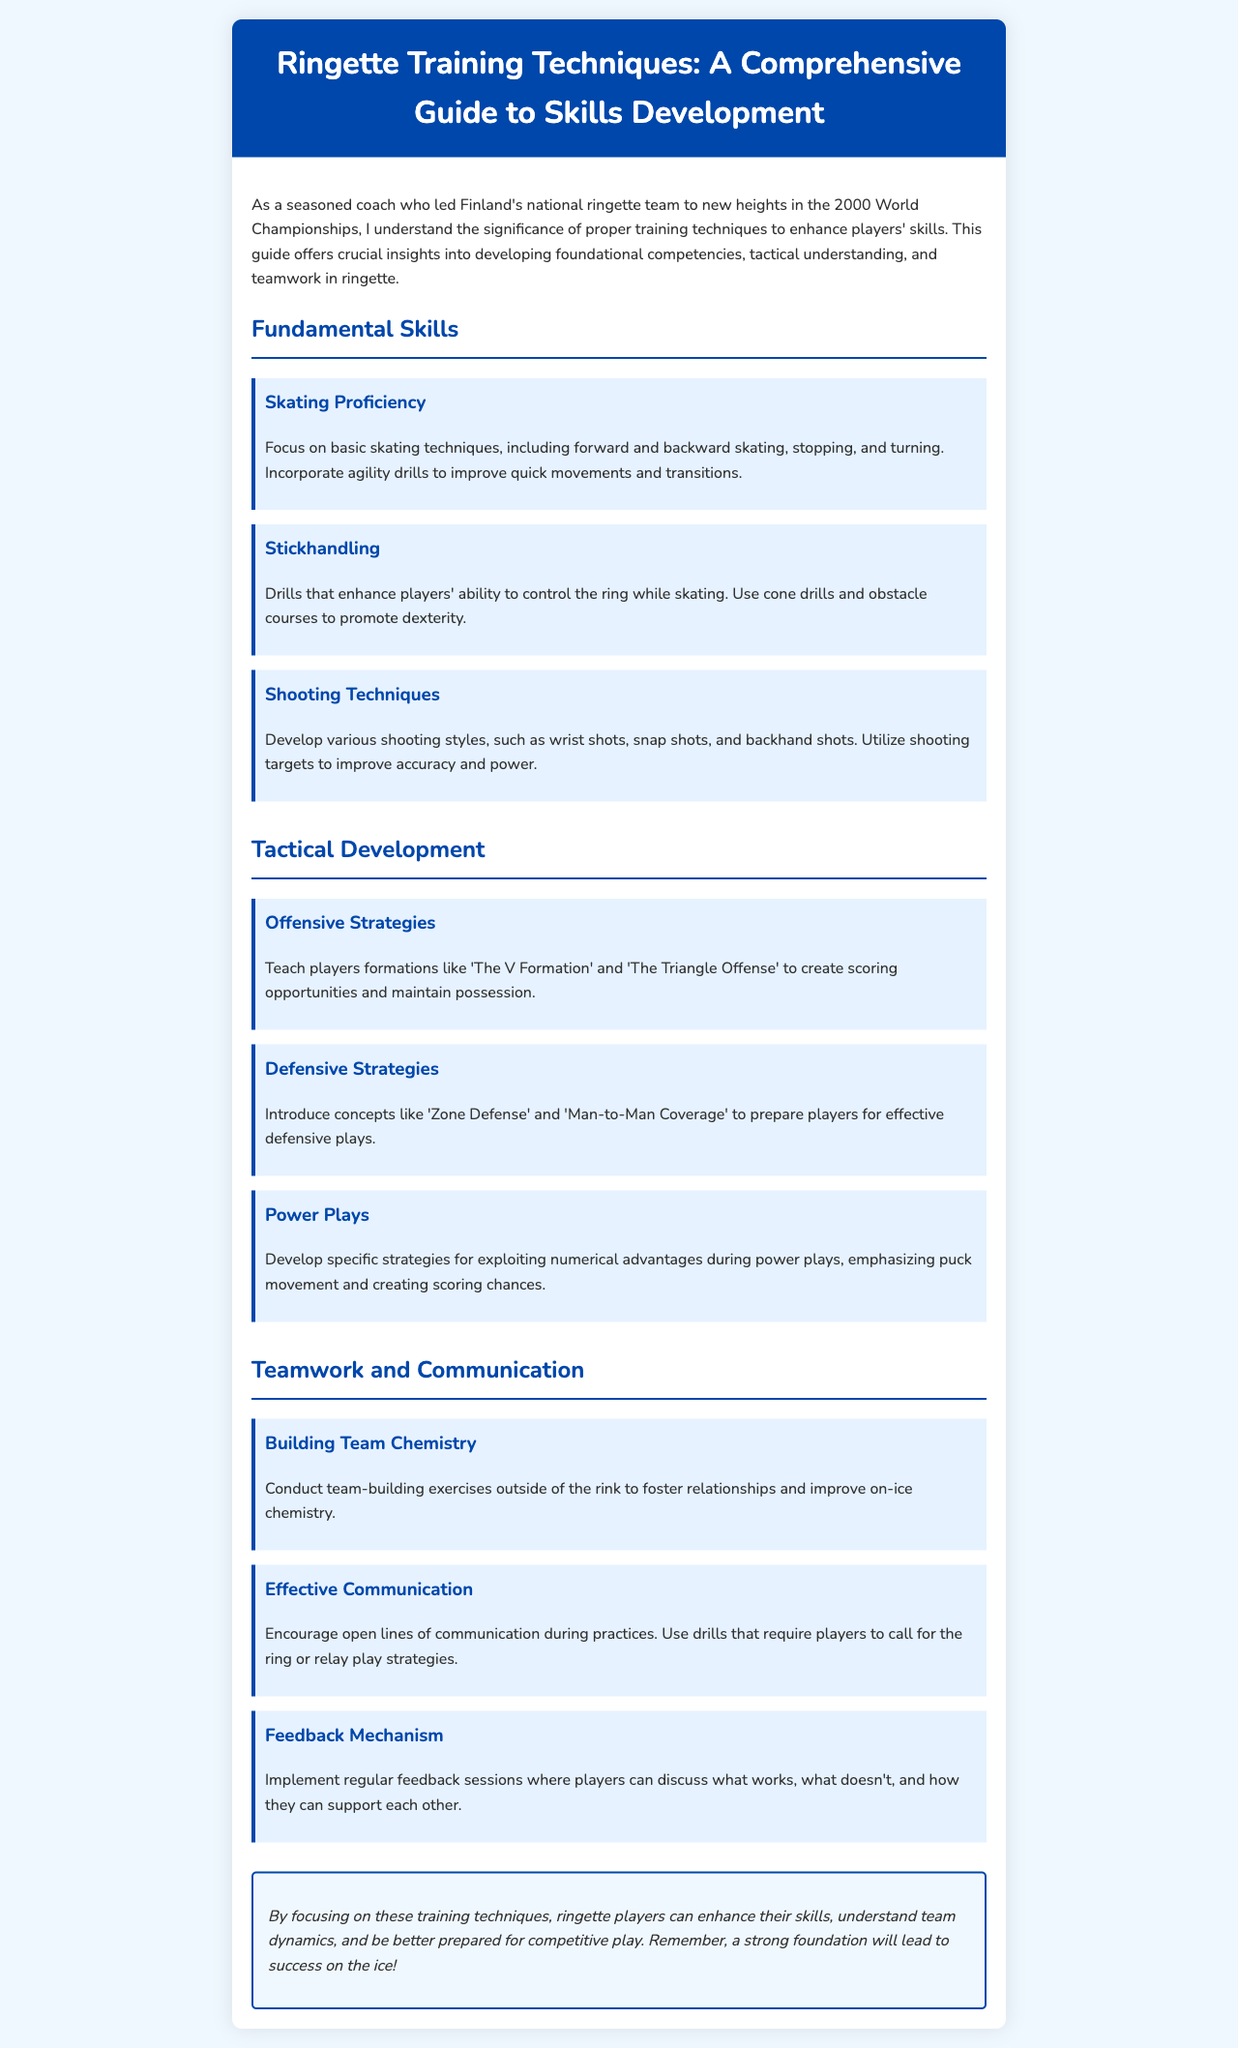What is the title of the brochure? The title of the brochure is presented in the header section, which introduces the main topic of the document.
Answer: Ringette Training Techniques: A Comprehensive Guide to Skills Development Who led Finland's national ringette team in the 2000 World Championships? The document mentions the author as a seasoned coach who guided the team in the 2000 World Championships, indicating their experience.
Answer: The author How many sections are in the content? The document is structured into distinct sections that focus on different aspects of training techniques in ringette.
Answer: Three What is one fundamental skill mentioned in the brochure? The brochure lists key areas of focus in skills development including fundamental skills, tactical development, and teamwork.
Answer: Skating Proficiency What is the primary focus of the Tactical Development section? This section elaborates on specific strategies that enhance gameplay during matches, providing a tactical overview for players.
Answer: Offensive Strategies What type of exercises are suggested for building team chemistry? The document emphasizes the importance of relationship-building to enhance teamwork dynamics on the ice.
Answer: Team-building exercises What should be encouraged during practices for effective communication? The emphasis on communication implies the need for players to stay engaged and coordinated during training sessions.
Answer: Open lines of communication What is a key component of the conclusion? The conclusion summarizes the importance of foundational training for overall success in ringette, emphasizing the document's central theme.
Answer: Strong foundation What does the brochure suggest for feedback mechanism? Regular feedback sessions are encouraged for ongoing improvement and support among players during training.
Answer: Regular feedback sessions 